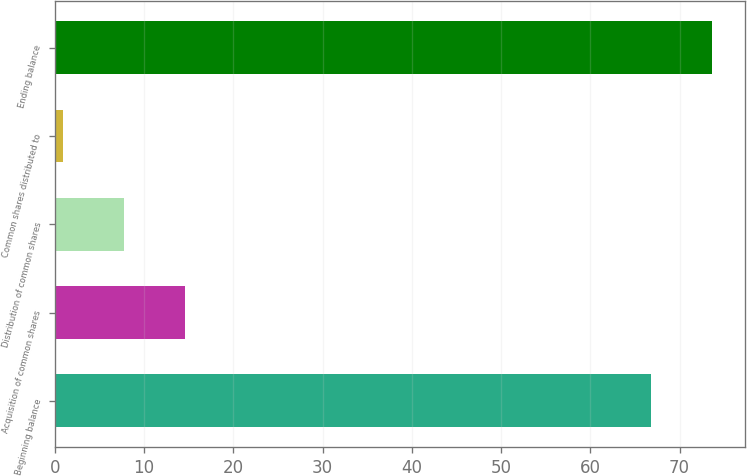Convert chart. <chart><loc_0><loc_0><loc_500><loc_500><bar_chart><fcel>Beginning balance<fcel>Acquisition of common shares<fcel>Distribution of common shares<fcel>Common shares distributed to<fcel>Ending balance<nl><fcel>66.8<fcel>14.6<fcel>7.75<fcel>0.9<fcel>73.65<nl></chart> 